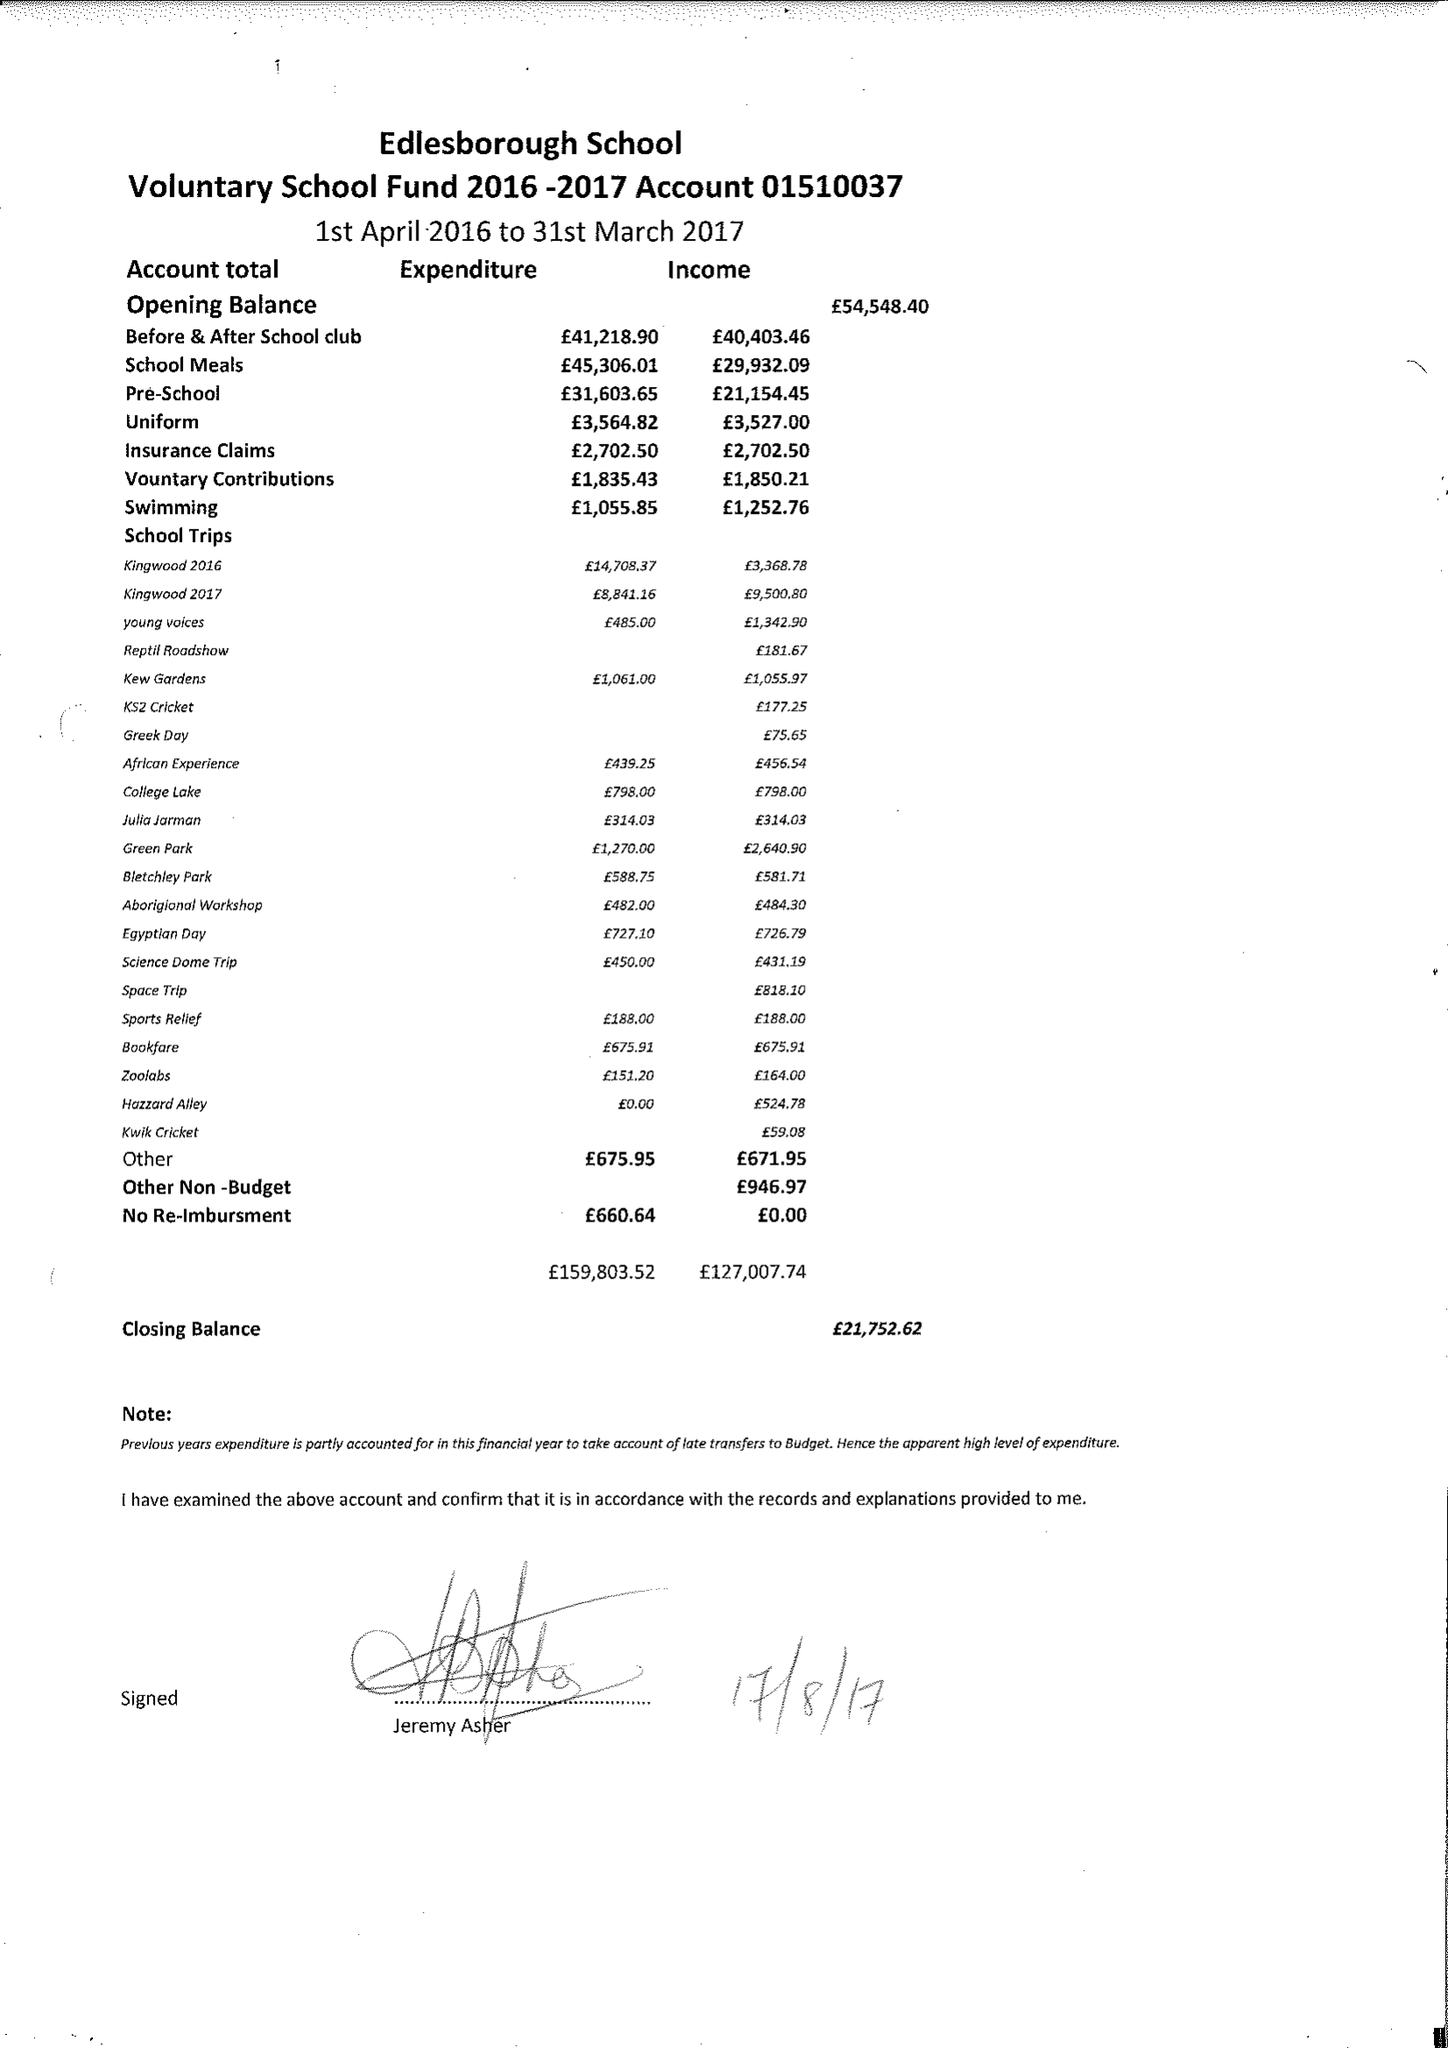What is the value for the address__postcode?
Answer the question using a single word or phrase. LU6 2HS 